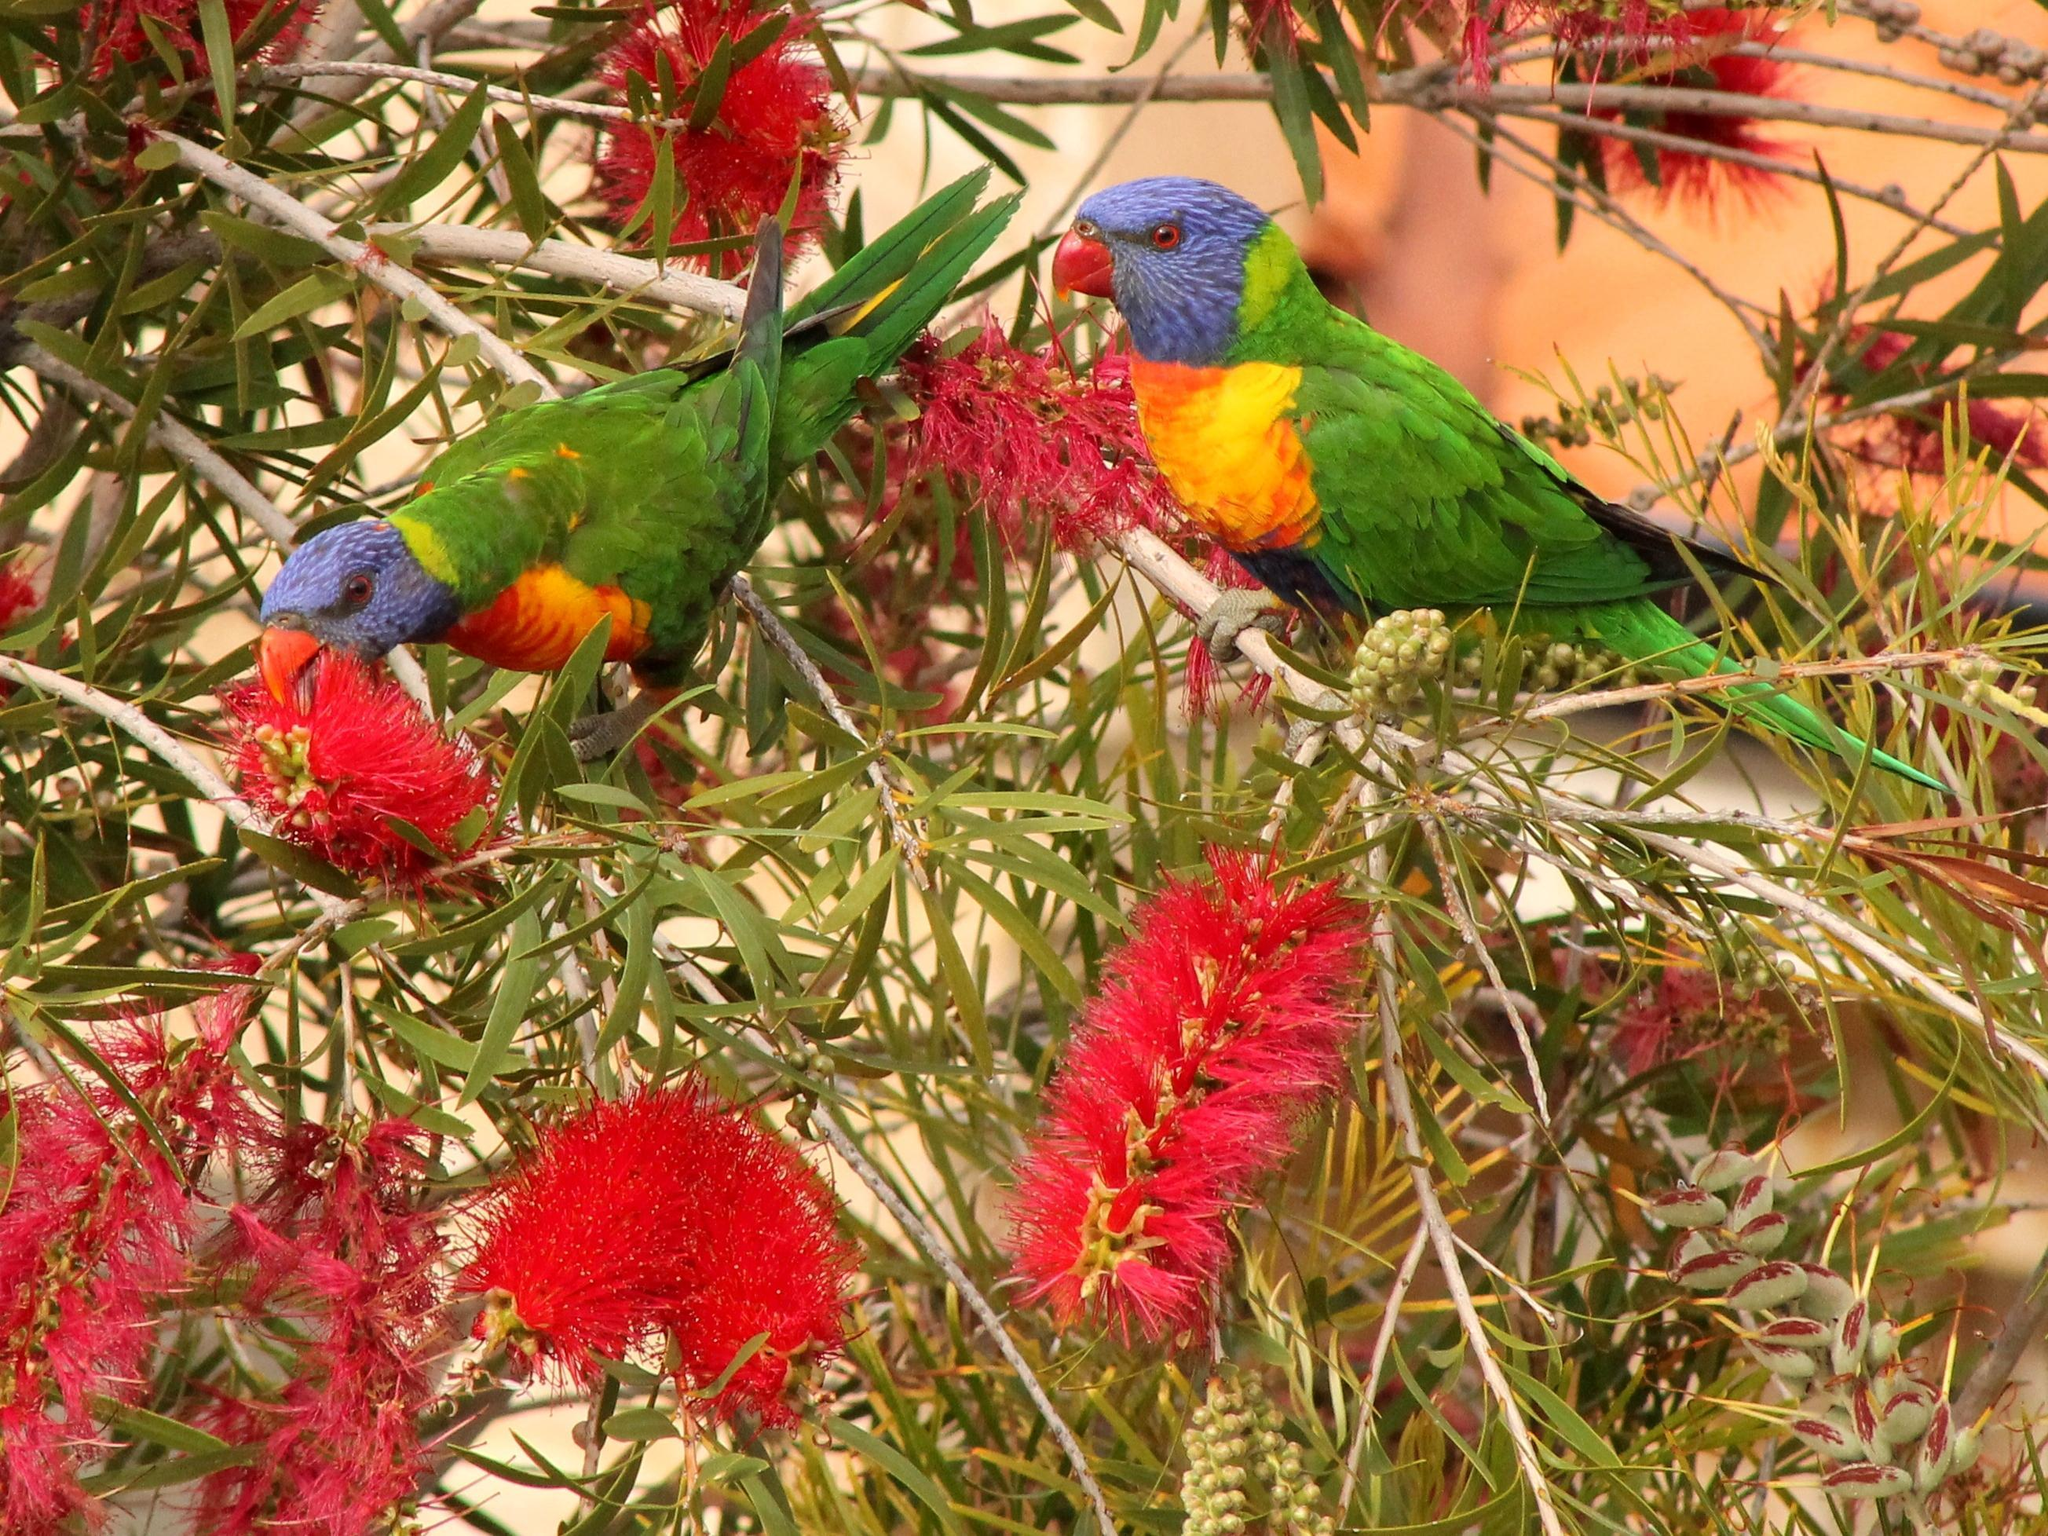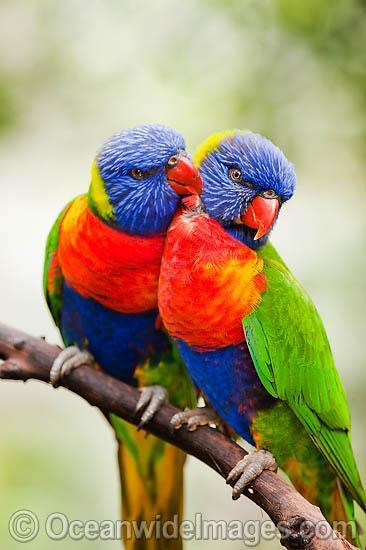The first image is the image on the left, the second image is the image on the right. Assess this claim about the two images: "There are two birds". Correct or not? Answer yes or no. No. 